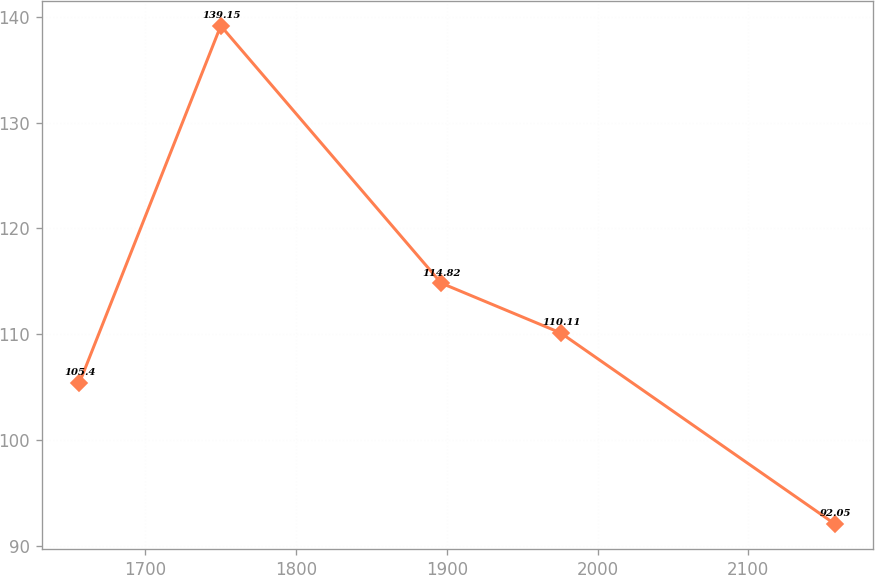Convert chart. <chart><loc_0><loc_0><loc_500><loc_500><line_chart><ecel><fcel>Unnamed: 1<nl><fcel>1656.44<fcel>105.4<nl><fcel>1750.15<fcel>139.15<nl><fcel>1896.32<fcel>114.82<nl><fcel>1975.56<fcel>110.11<nl><fcel>2157.32<fcel>92.05<nl></chart> 